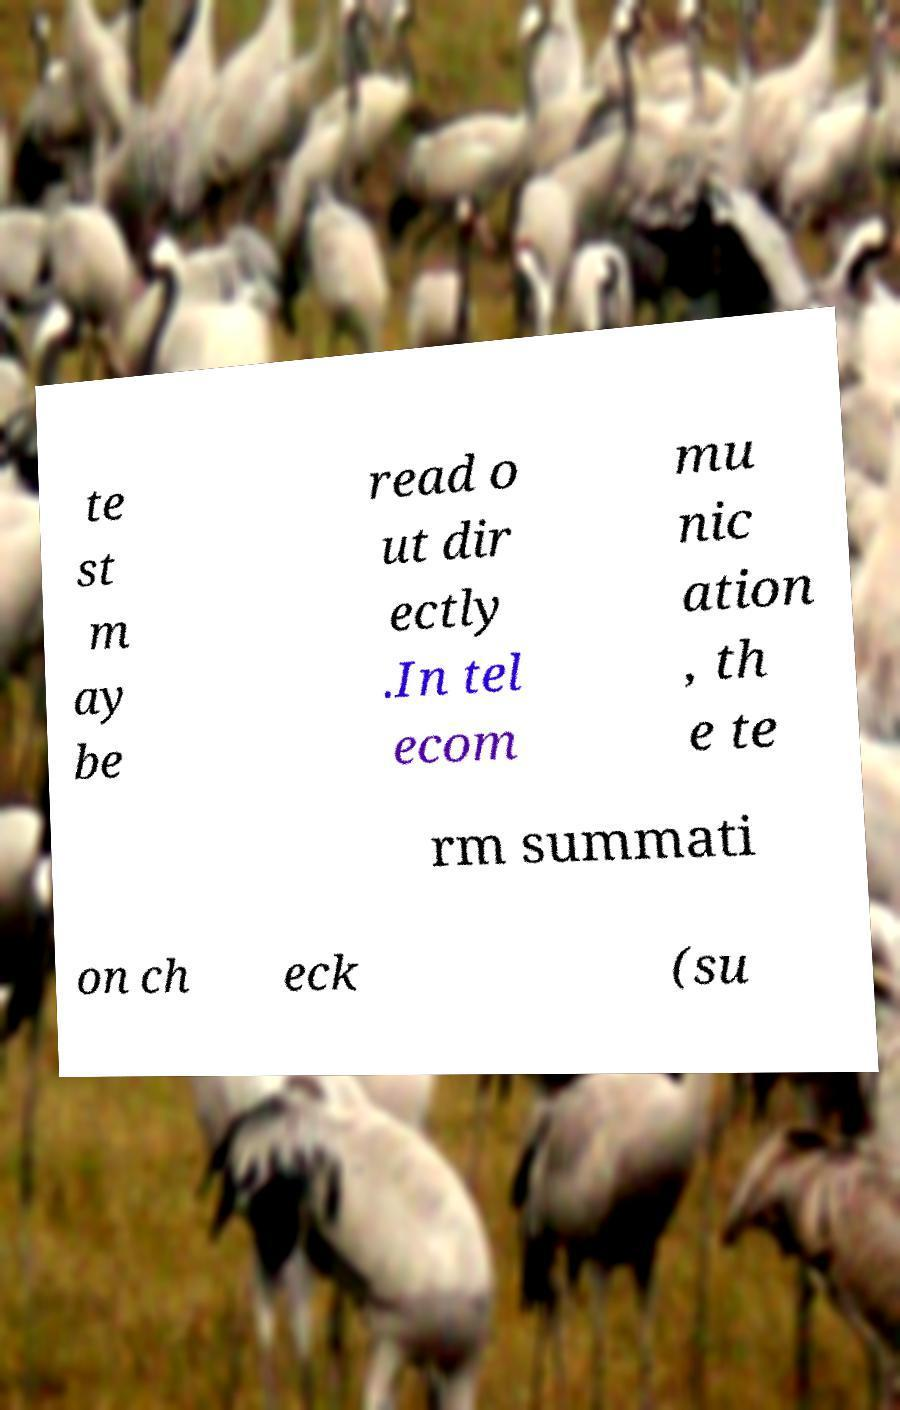Can you read and provide the text displayed in the image?This photo seems to have some interesting text. Can you extract and type it out for me? te st m ay be read o ut dir ectly .In tel ecom mu nic ation , th e te rm summati on ch eck (su 